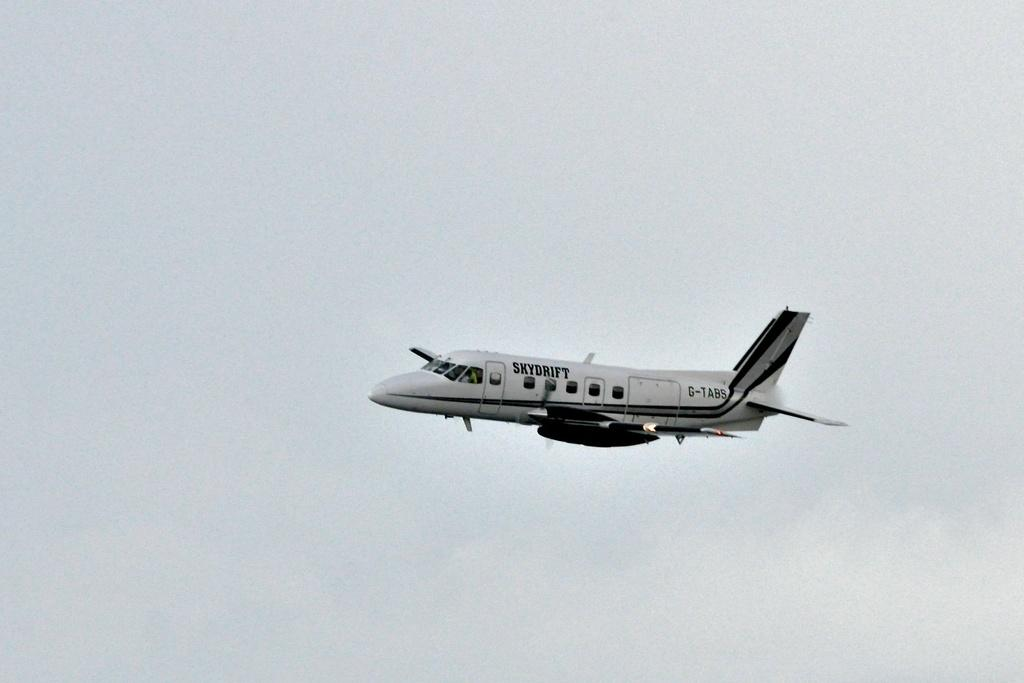What is the main subject of the picture? The main subject of the picture is an airplane. What is the color of the airplane? The airplane is white in color. How would you describe the sky in the picture? The sky is cloudy in the picture. What type of cake is being served on the airplane in the image? There is no cake or indication of food being served in the image; it only features an airplane. What type of attraction is visible near the airplane in the image? There is no attraction visible in the image; it only features an airplane and a cloudy sky. 